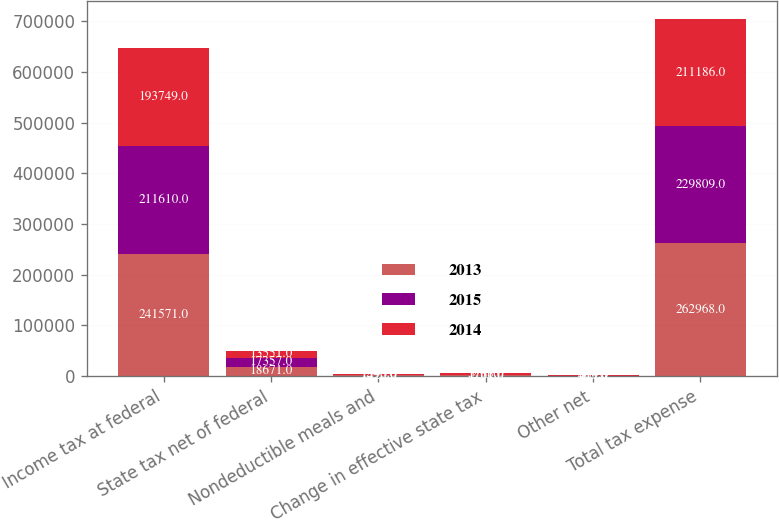<chart> <loc_0><loc_0><loc_500><loc_500><stacked_bar_chart><ecel><fcel>Income tax at federal<fcel>State tax net of federal<fcel>Nondeductible meals and<fcel>Change in effective state tax<fcel>Other net<fcel>Total tax expense<nl><fcel>2013<fcel>241571<fcel>18671<fcel>1420<fcel>1761<fcel>455<fcel>262968<nl><fcel>2015<fcel>211610<fcel>17357<fcel>1395<fcel>256<fcel>809<fcel>229809<nl><fcel>2014<fcel>193749<fcel>13551<fcel>1543<fcel>3708<fcel>610<fcel>211186<nl></chart> 